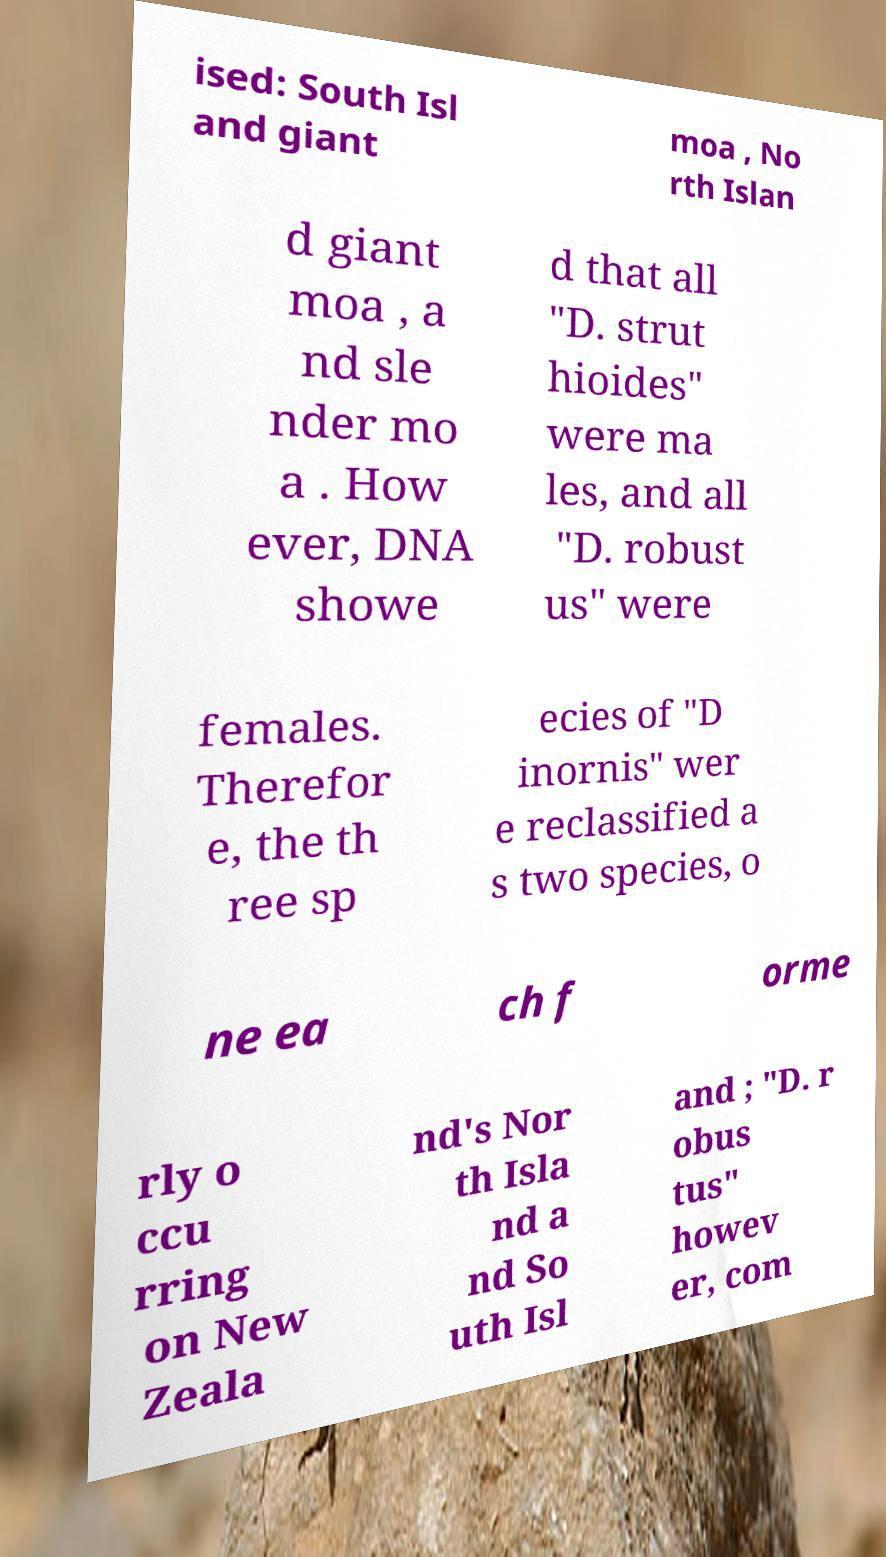Please read and relay the text visible in this image. What does it say? ised: South Isl and giant moa , No rth Islan d giant moa , a nd sle nder mo a . How ever, DNA showe d that all "D. strut hioides" were ma les, and all "D. robust us" were females. Therefor e, the th ree sp ecies of "D inornis" wer e reclassified a s two species, o ne ea ch f orme rly o ccu rring on New Zeala nd's Nor th Isla nd a nd So uth Isl and ; "D. r obus tus" howev er, com 